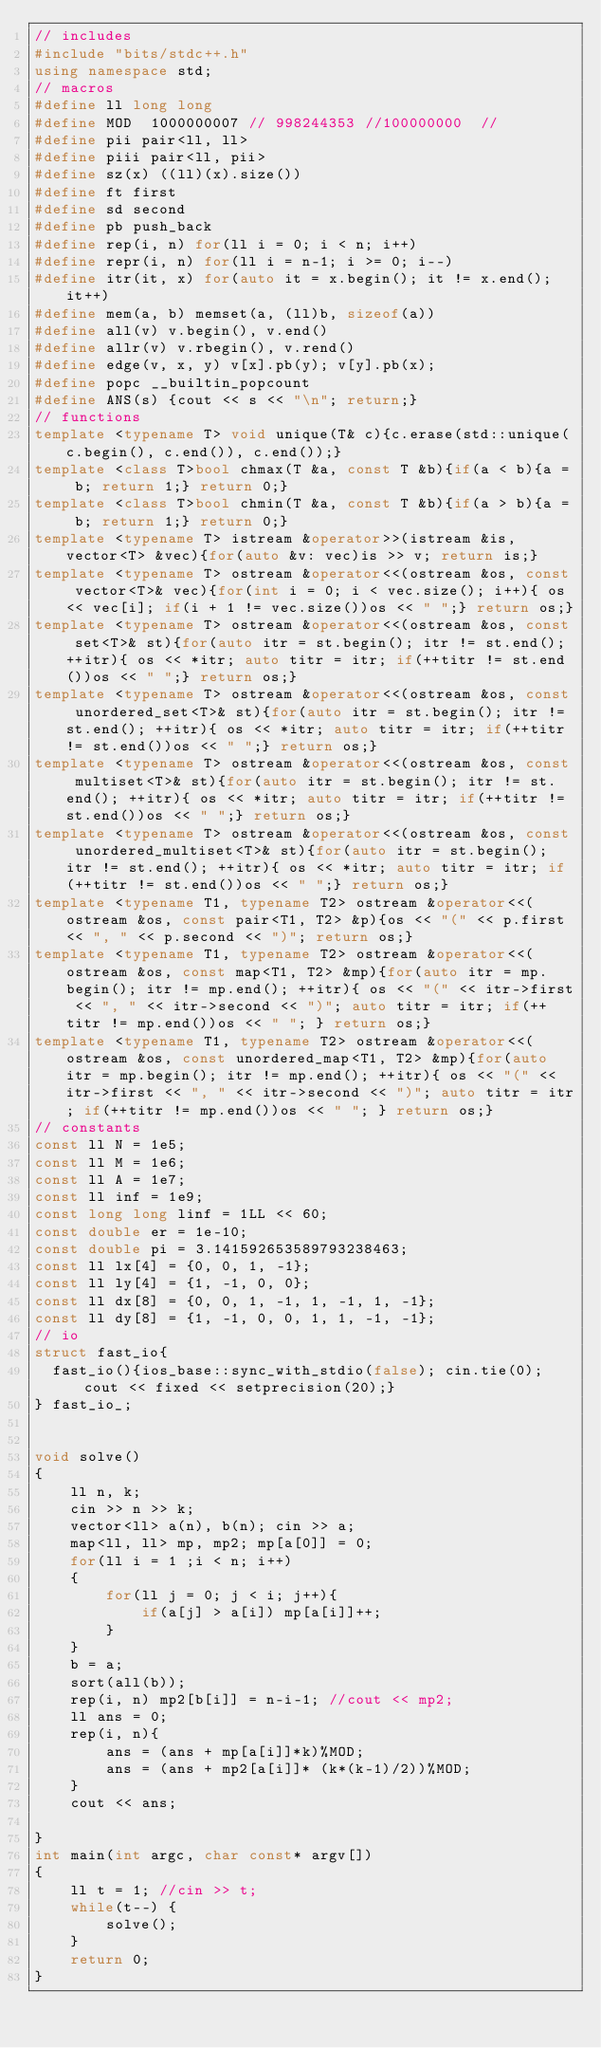<code> <loc_0><loc_0><loc_500><loc_500><_C++_>// includes
#include "bits/stdc++.h"
using namespace std;
// macros
#define ll long long
#define MOD  1000000007 // 998244353 //100000000  //
#define pii pair<ll, ll>
#define piii pair<ll, pii>
#define sz(x) ((ll)(x).size())
#define ft first
#define sd second
#define pb push_back
#define rep(i, n) for(ll i = 0; i < n; i++)
#define repr(i, n) for(ll i = n-1; i >= 0; i--)
#define itr(it, x) for(auto it = x.begin(); it != x.end(); it++)
#define mem(a, b) memset(a, (ll)b, sizeof(a))
#define all(v) v.begin(), v.end()
#define allr(v) v.rbegin(), v.rend()
#define edge(v, x, y) v[x].pb(y); v[y].pb(x);
#define popc __builtin_popcount
#define ANS(s) {cout << s << "\n"; return;}
// functions
template <typename T> void unique(T& c){c.erase(std::unique(c.begin(), c.end()), c.end());}
template <class T>bool chmax(T &a, const T &b){if(a < b){a = b; return 1;} return 0;}
template <class T>bool chmin(T &a, const T &b){if(a > b){a = b; return 1;} return 0;}
template <typename T> istream &operator>>(istream &is, vector<T> &vec){for(auto &v: vec)is >> v; return is;}
template <typename T> ostream &operator<<(ostream &os, const vector<T>& vec){for(int i = 0; i < vec.size(); i++){ os << vec[i]; if(i + 1 != vec.size())os << " ";} return os;}
template <typename T> ostream &operator<<(ostream &os, const set<T>& st){for(auto itr = st.begin(); itr != st.end(); ++itr){ os << *itr; auto titr = itr; if(++titr != st.end())os << " ";} return os;}
template <typename T> ostream &operator<<(ostream &os, const unordered_set<T>& st){for(auto itr = st.begin(); itr != st.end(); ++itr){ os << *itr; auto titr = itr; if(++titr != st.end())os << " ";} return os;}
template <typename T> ostream &operator<<(ostream &os, const multiset<T>& st){for(auto itr = st.begin(); itr != st.end(); ++itr){ os << *itr; auto titr = itr; if(++titr != st.end())os << " ";} return os;}
template <typename T> ostream &operator<<(ostream &os, const unordered_multiset<T>& st){for(auto itr = st.begin(); itr != st.end(); ++itr){ os << *itr; auto titr = itr; if(++titr != st.end())os << " ";} return os;}
template <typename T1, typename T2> ostream &operator<<(ostream &os, const pair<T1, T2> &p){os << "(" << p.first << ", " << p.second << ")"; return os;}
template <typename T1, typename T2> ostream &operator<<(ostream &os, const map<T1, T2> &mp){for(auto itr = mp.begin(); itr != mp.end(); ++itr){ os << "(" << itr->first << ", " << itr->second << ")"; auto titr = itr; if(++titr != mp.end())os << " "; } return os;}
template <typename T1, typename T2> ostream &operator<<(ostream &os, const unordered_map<T1, T2> &mp){for(auto itr = mp.begin(); itr != mp.end(); ++itr){ os << "(" << itr->first << ", " << itr->second << ")"; auto titr = itr; if(++titr != mp.end())os << " "; } return os;}
// constants
const ll N = 1e5;
const ll M = 1e6;
const ll A = 1e7;
const ll inf = 1e9;
const long long linf = 1LL << 60;
const double er = 1e-10;
const double pi = 3.141592653589793238463;
const ll lx[4] = {0, 0, 1, -1};
const ll ly[4] = {1, -1, 0, 0};
const ll dx[8] = {0, 0, 1, -1, 1, -1, 1, -1};
const ll dy[8] = {1, -1, 0, 0, 1, 1, -1, -1};
// io
struct fast_io{
  fast_io(){ios_base::sync_with_stdio(false); cin.tie(0); cout << fixed << setprecision(20);}
} fast_io_;


void solve()
{
    ll n, k;
    cin >> n >> k;
    vector<ll> a(n), b(n); cin >> a;
    map<ll, ll> mp, mp2; mp[a[0]] = 0;
    for(ll i = 1 ;i < n; i++)
    {
        for(ll j = 0; j < i; j++){
            if(a[j] > a[i]) mp[a[i]]++;
        }
    }
    b = a;
    sort(all(b));
    rep(i, n) mp2[b[i]] = n-i-1; //cout << mp2;
    ll ans = 0;
    rep(i, n){
        ans = (ans + mp[a[i]]*k)%MOD;
        ans = (ans + mp2[a[i]]* (k*(k-1)/2))%MOD;
    }
    cout << ans;

}
int main(int argc, char const* argv[])
{
    ll t = 1; //cin >> t;
    while(t--) {
        solve();
    }
    return 0;
}
</code> 